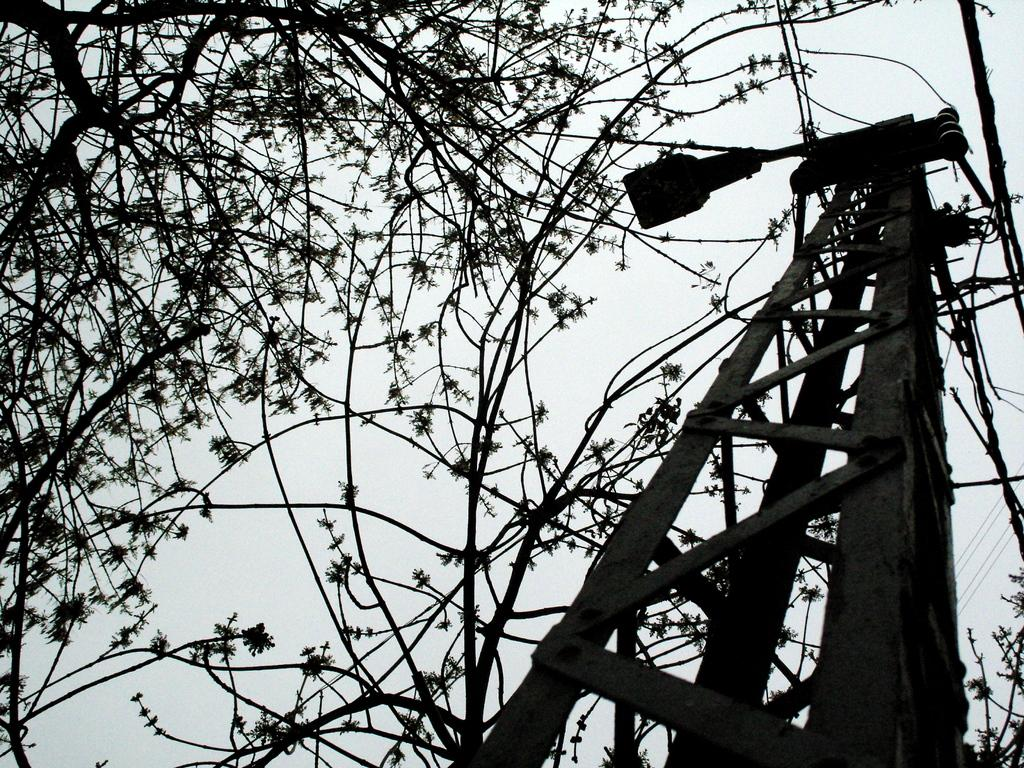What type of vegetation can be seen in the image? There are tree branches in the image. What structures are present in the image? There are poles in the image. What is visible in the background of the image? The sky is visible in the image. What type of sand can be seen on the poles in the image? There is no sand present on the poles in the image. What color is the celery in the image? There is no celery present in the image. 